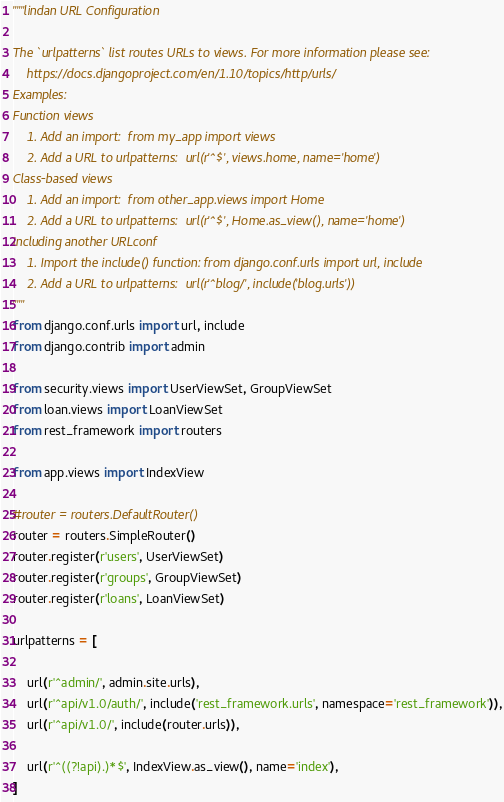Convert code to text. <code><loc_0><loc_0><loc_500><loc_500><_Python_>"""lindan URL Configuration

The `urlpatterns` list routes URLs to views. For more information please see:
    https://docs.djangoproject.com/en/1.10/topics/http/urls/
Examples:
Function views
    1. Add an import:  from my_app import views
    2. Add a URL to urlpatterns:  url(r'^$', views.home, name='home')
Class-based views
    1. Add an import:  from other_app.views import Home
    2. Add a URL to urlpatterns:  url(r'^$', Home.as_view(), name='home')
Including another URLconf
    1. Import the include() function: from django.conf.urls import url, include
    2. Add a URL to urlpatterns:  url(r'^blog/', include('blog.urls'))
"""
from django.conf.urls import url, include
from django.contrib import admin

from security.views import UserViewSet, GroupViewSet
from loan.views import LoanViewSet
from rest_framework import routers

from app.views import IndexView

#router = routers.DefaultRouter()
router = routers.SimpleRouter()
router.register(r'users', UserViewSet)
router.register(r'groups', GroupViewSet)
router.register(r'loans', LoanViewSet)

urlpatterns = [
    
    url(r'^admin/', admin.site.urls),
    url(r'^api/v1.0/auth/', include('rest_framework.urls', namespace='rest_framework')),
    url(r'^api/v1.0/', include(router.urls)),
    
    url(r'^((?!api).)*$', IndexView.as_view(), name='index'),
]
</code> 